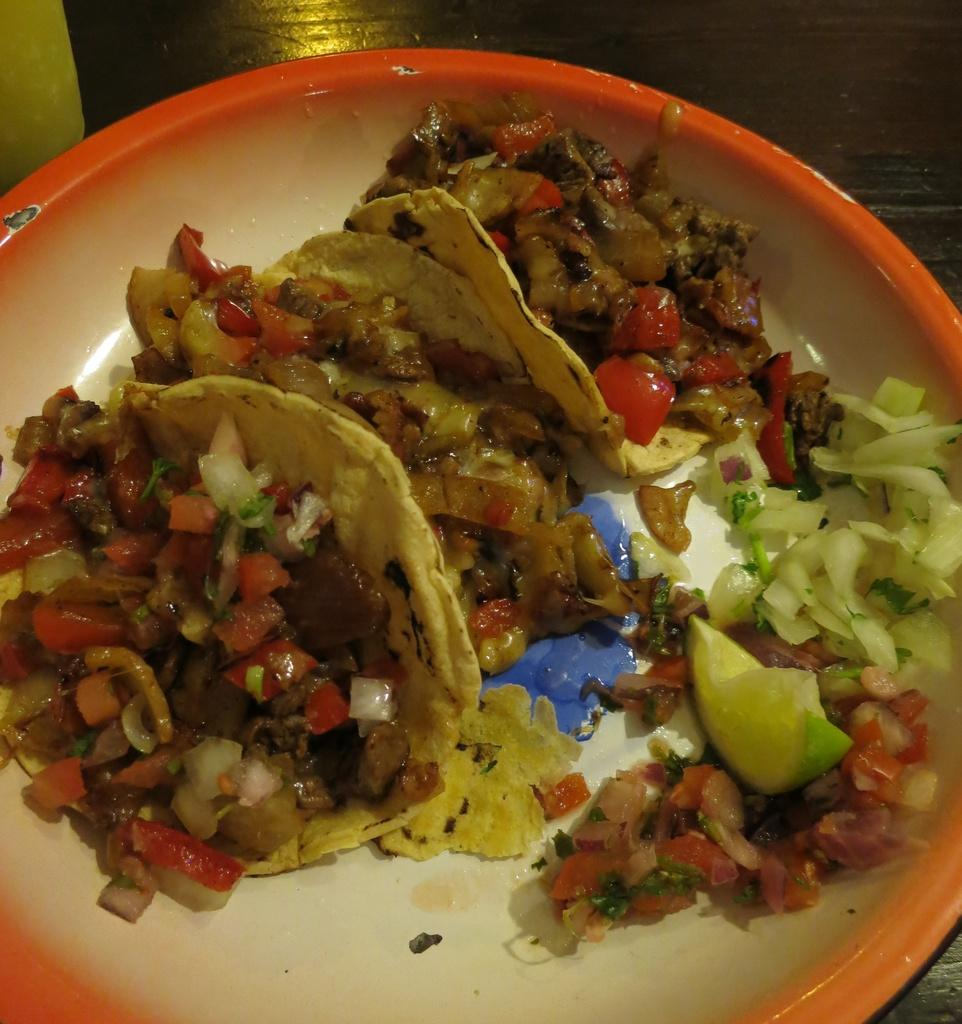What is on the plate that is visible in the image? There is food on a plate in the image. Where is the plate located in the image? The plate is placed on a table. What type of pet can be seen sitting next to the plate in the image? There is no pet present in the image; it only shows a plate of food on a table. 